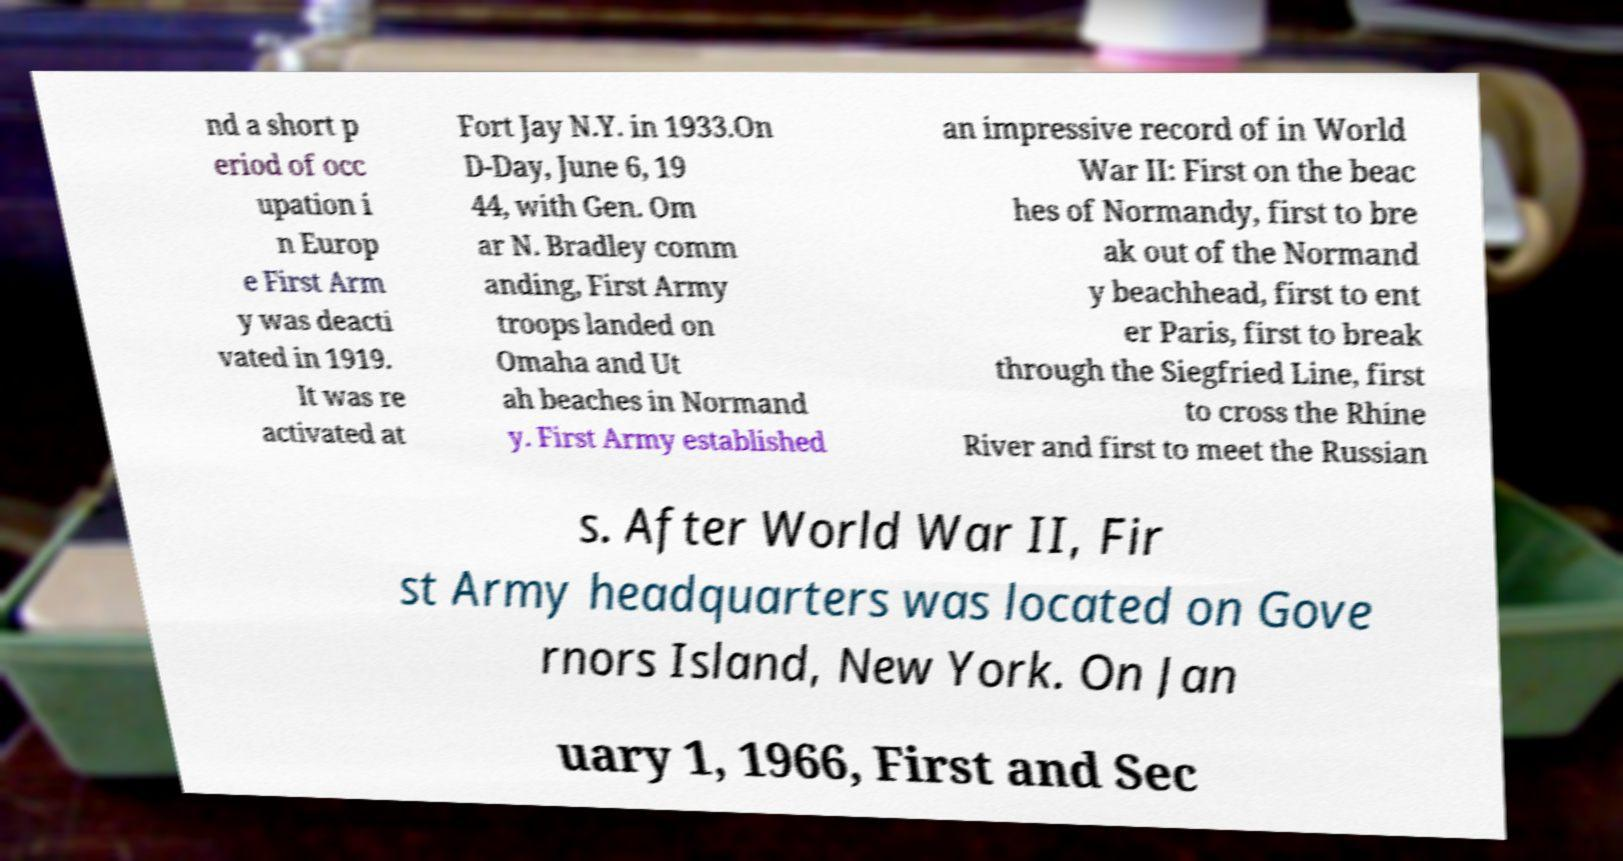Could you extract and type out the text from this image? nd a short p eriod of occ upation i n Europ e First Arm y was deacti vated in 1919. It was re activated at Fort Jay N.Y. in 1933.On D-Day, June 6, 19 44, with Gen. Om ar N. Bradley comm anding, First Army troops landed on Omaha and Ut ah beaches in Normand y. First Army established an impressive record of in World War II: First on the beac hes of Normandy, first to bre ak out of the Normand y beachhead, first to ent er Paris, first to break through the Siegfried Line, first to cross the Rhine River and first to meet the Russian s. After World War II, Fir st Army headquarters was located on Gove rnors Island, New York. On Jan uary 1, 1966, First and Sec 